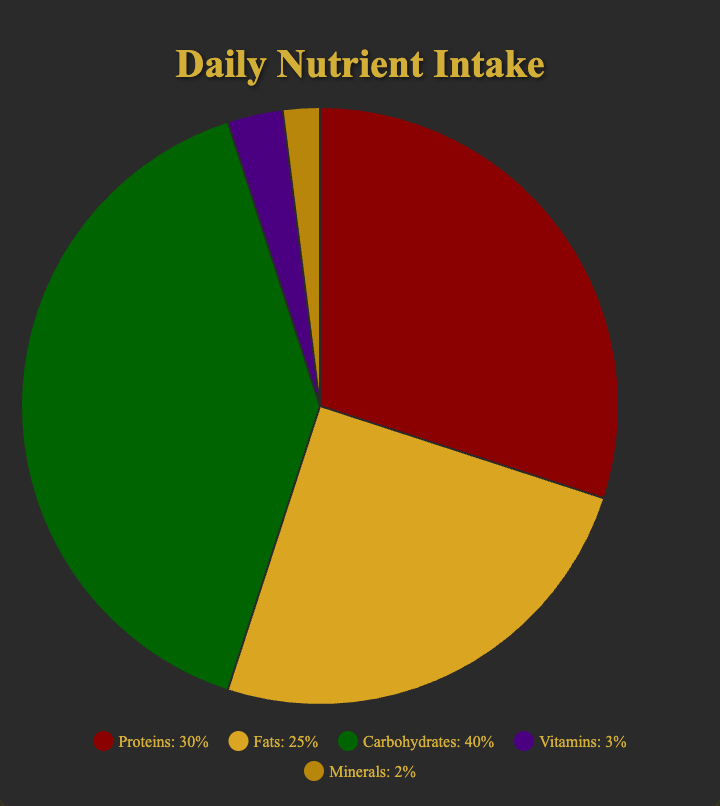What nutrient has the highest percentage of daily intake? The pie chart shows that the carbohydrate section occupies the largest part of the pie with a 40% share.
Answer: Carbohydrates What is the total percentage of proteins and fats combined? Adding the percentage of proteins which is 30% with the percentage of fats which is 25%, we get 30 + 25 = 55%.
Answer: 55% Which nutrient has the lowest daily intake percentage? The pie chart shows that minerals occupy the smallest portion of the chart with only 2%.
Answer: Minerals Compare the daily intake percentages of proteins and carbohydrates. Which one is larger and by how much? Carbohydrates have a daily intake of 40%, and proteins have 30%. The difference between them is 40 - 30 = 10%.
Answer: Carbohydrates by 10% What is the total percentage allocated to vitamins and minerals together? Adding the percentage of vitamins which is 3% with the percentage of minerals which is 2%, we get 3 + 2 = 5%.
Answer: 5% How many nutrients have a daily intake percentage greater than 20%? The pie chart indicates that proteins (30%), fats (25%), and carbohydrates (40%) all have daily intake percentages greater than 20%. So there are 3 nutrients.
Answer: 3 What is the commonly shared color of nutrients that make up more than 50% of the daily intake? The sectors for proteins, fats, and carbohydrates, which combined total more than 50% of daily intake, are colored red (proteins), gold (fats), and green (carbohydrates). No single color is shared.
Answer: None If you were to equally distribute 10% among vitamins and minerals, what would be their new percentages? Initially, vitamins are at 3% and minerals at 2%. Adding 5% to each would give new values of 3 + 5 = 8% for vitamins and 2 + 5 = 7% for minerals.
Answer: Vitamins: 8%, Minerals: 7% If the intake percentage of fats increased by 5%, what would be the new percentage allocation of fats and the total percentage covered by all nutrients? Currently, fats are at 25%. Adding 5% makes it 25 + 5 = 30%. The total of all nutrients is currently 100%. Adding the 5% fat increase to this keeps the total at 100% (since we assume proportions can adjust to accommodate the increase)
Answer: Fats: 30%, Total: 100% What proportion of daily nutrient intake is attributed to non-carbohydrates? Carbohydrates make up 40% of the daily intake. Therefore, non-carbohydrates make up the remaining, which is 100% - 40% = 60%.
Answer: 60% 